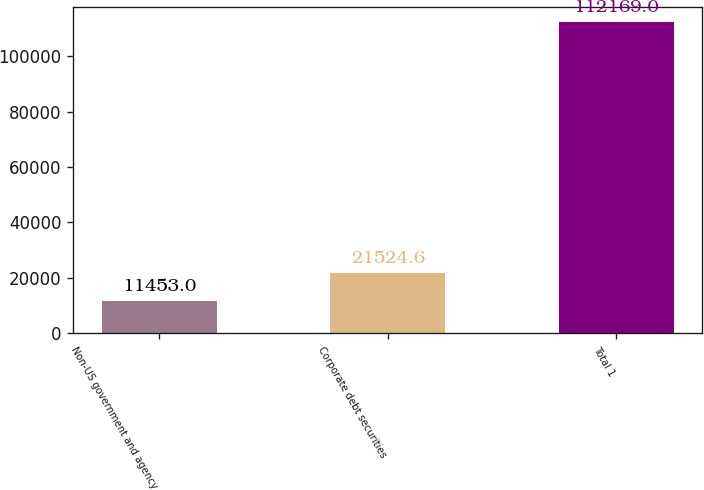Convert chart. <chart><loc_0><loc_0><loc_500><loc_500><bar_chart><fcel>Non-US government and agency<fcel>Corporate debt securities<fcel>Total 1<nl><fcel>11453<fcel>21524.6<fcel>112169<nl></chart> 